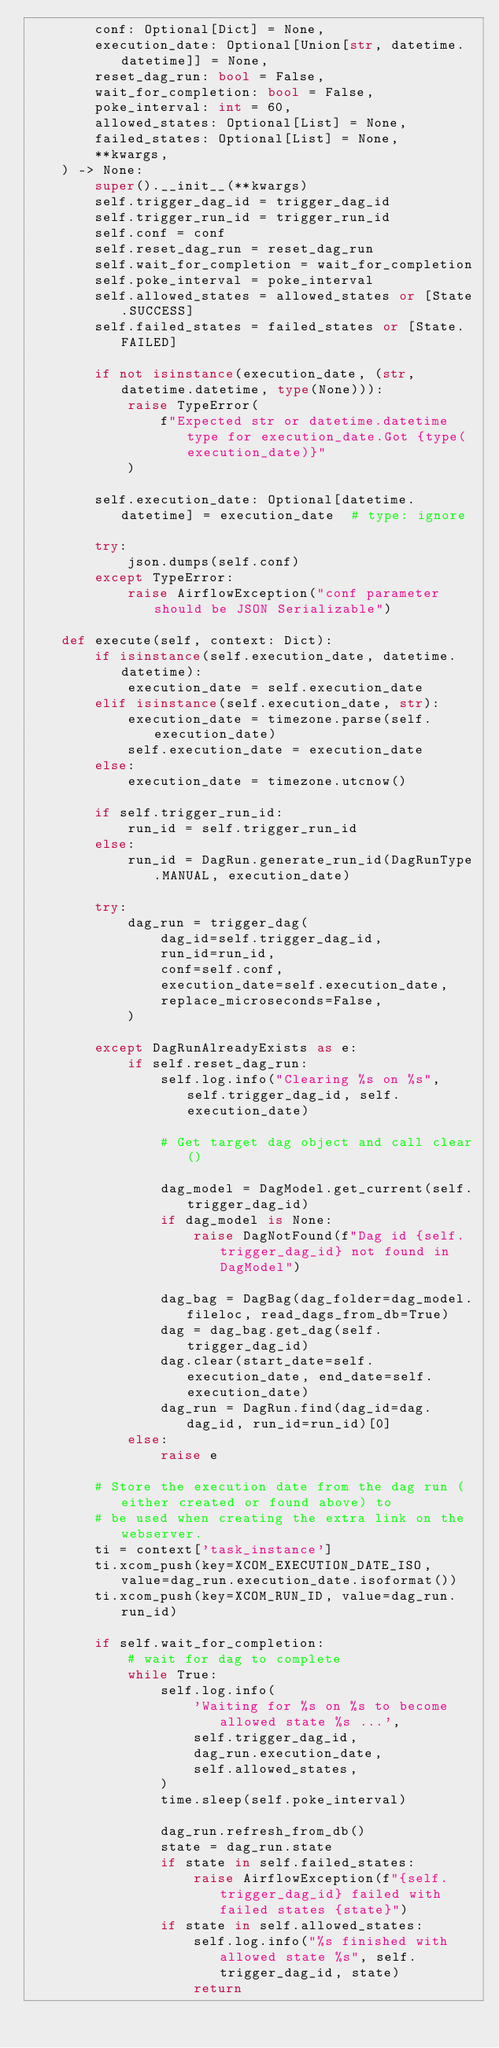Convert code to text. <code><loc_0><loc_0><loc_500><loc_500><_Python_>        conf: Optional[Dict] = None,
        execution_date: Optional[Union[str, datetime.datetime]] = None,
        reset_dag_run: bool = False,
        wait_for_completion: bool = False,
        poke_interval: int = 60,
        allowed_states: Optional[List] = None,
        failed_states: Optional[List] = None,
        **kwargs,
    ) -> None:
        super().__init__(**kwargs)
        self.trigger_dag_id = trigger_dag_id
        self.trigger_run_id = trigger_run_id
        self.conf = conf
        self.reset_dag_run = reset_dag_run
        self.wait_for_completion = wait_for_completion
        self.poke_interval = poke_interval
        self.allowed_states = allowed_states or [State.SUCCESS]
        self.failed_states = failed_states or [State.FAILED]

        if not isinstance(execution_date, (str, datetime.datetime, type(None))):
            raise TypeError(
                f"Expected str or datetime.datetime type for execution_date.Got {type(execution_date)}"
            )

        self.execution_date: Optional[datetime.datetime] = execution_date  # type: ignore

        try:
            json.dumps(self.conf)
        except TypeError:
            raise AirflowException("conf parameter should be JSON Serializable")

    def execute(self, context: Dict):
        if isinstance(self.execution_date, datetime.datetime):
            execution_date = self.execution_date
        elif isinstance(self.execution_date, str):
            execution_date = timezone.parse(self.execution_date)
            self.execution_date = execution_date
        else:
            execution_date = timezone.utcnow()

        if self.trigger_run_id:
            run_id = self.trigger_run_id
        else:
            run_id = DagRun.generate_run_id(DagRunType.MANUAL, execution_date)

        try:
            dag_run = trigger_dag(
                dag_id=self.trigger_dag_id,
                run_id=run_id,
                conf=self.conf,
                execution_date=self.execution_date,
                replace_microseconds=False,
            )

        except DagRunAlreadyExists as e:
            if self.reset_dag_run:
                self.log.info("Clearing %s on %s", self.trigger_dag_id, self.execution_date)

                # Get target dag object and call clear()

                dag_model = DagModel.get_current(self.trigger_dag_id)
                if dag_model is None:
                    raise DagNotFound(f"Dag id {self.trigger_dag_id} not found in DagModel")

                dag_bag = DagBag(dag_folder=dag_model.fileloc, read_dags_from_db=True)
                dag = dag_bag.get_dag(self.trigger_dag_id)
                dag.clear(start_date=self.execution_date, end_date=self.execution_date)
                dag_run = DagRun.find(dag_id=dag.dag_id, run_id=run_id)[0]
            else:
                raise e

        # Store the execution date from the dag run (either created or found above) to
        # be used when creating the extra link on the webserver.
        ti = context['task_instance']
        ti.xcom_push(key=XCOM_EXECUTION_DATE_ISO, value=dag_run.execution_date.isoformat())
        ti.xcom_push(key=XCOM_RUN_ID, value=dag_run.run_id)

        if self.wait_for_completion:
            # wait for dag to complete
            while True:
                self.log.info(
                    'Waiting for %s on %s to become allowed state %s ...',
                    self.trigger_dag_id,
                    dag_run.execution_date,
                    self.allowed_states,
                )
                time.sleep(self.poke_interval)

                dag_run.refresh_from_db()
                state = dag_run.state
                if state in self.failed_states:
                    raise AirflowException(f"{self.trigger_dag_id} failed with failed states {state}")
                if state in self.allowed_states:
                    self.log.info("%s finished with allowed state %s", self.trigger_dag_id, state)
                    return
</code> 